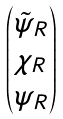<formula> <loc_0><loc_0><loc_500><loc_500>\begin{pmatrix} \tilde { \psi } _ { R } \\ \chi _ { R } \\ \psi _ { R } \end{pmatrix}</formula> 